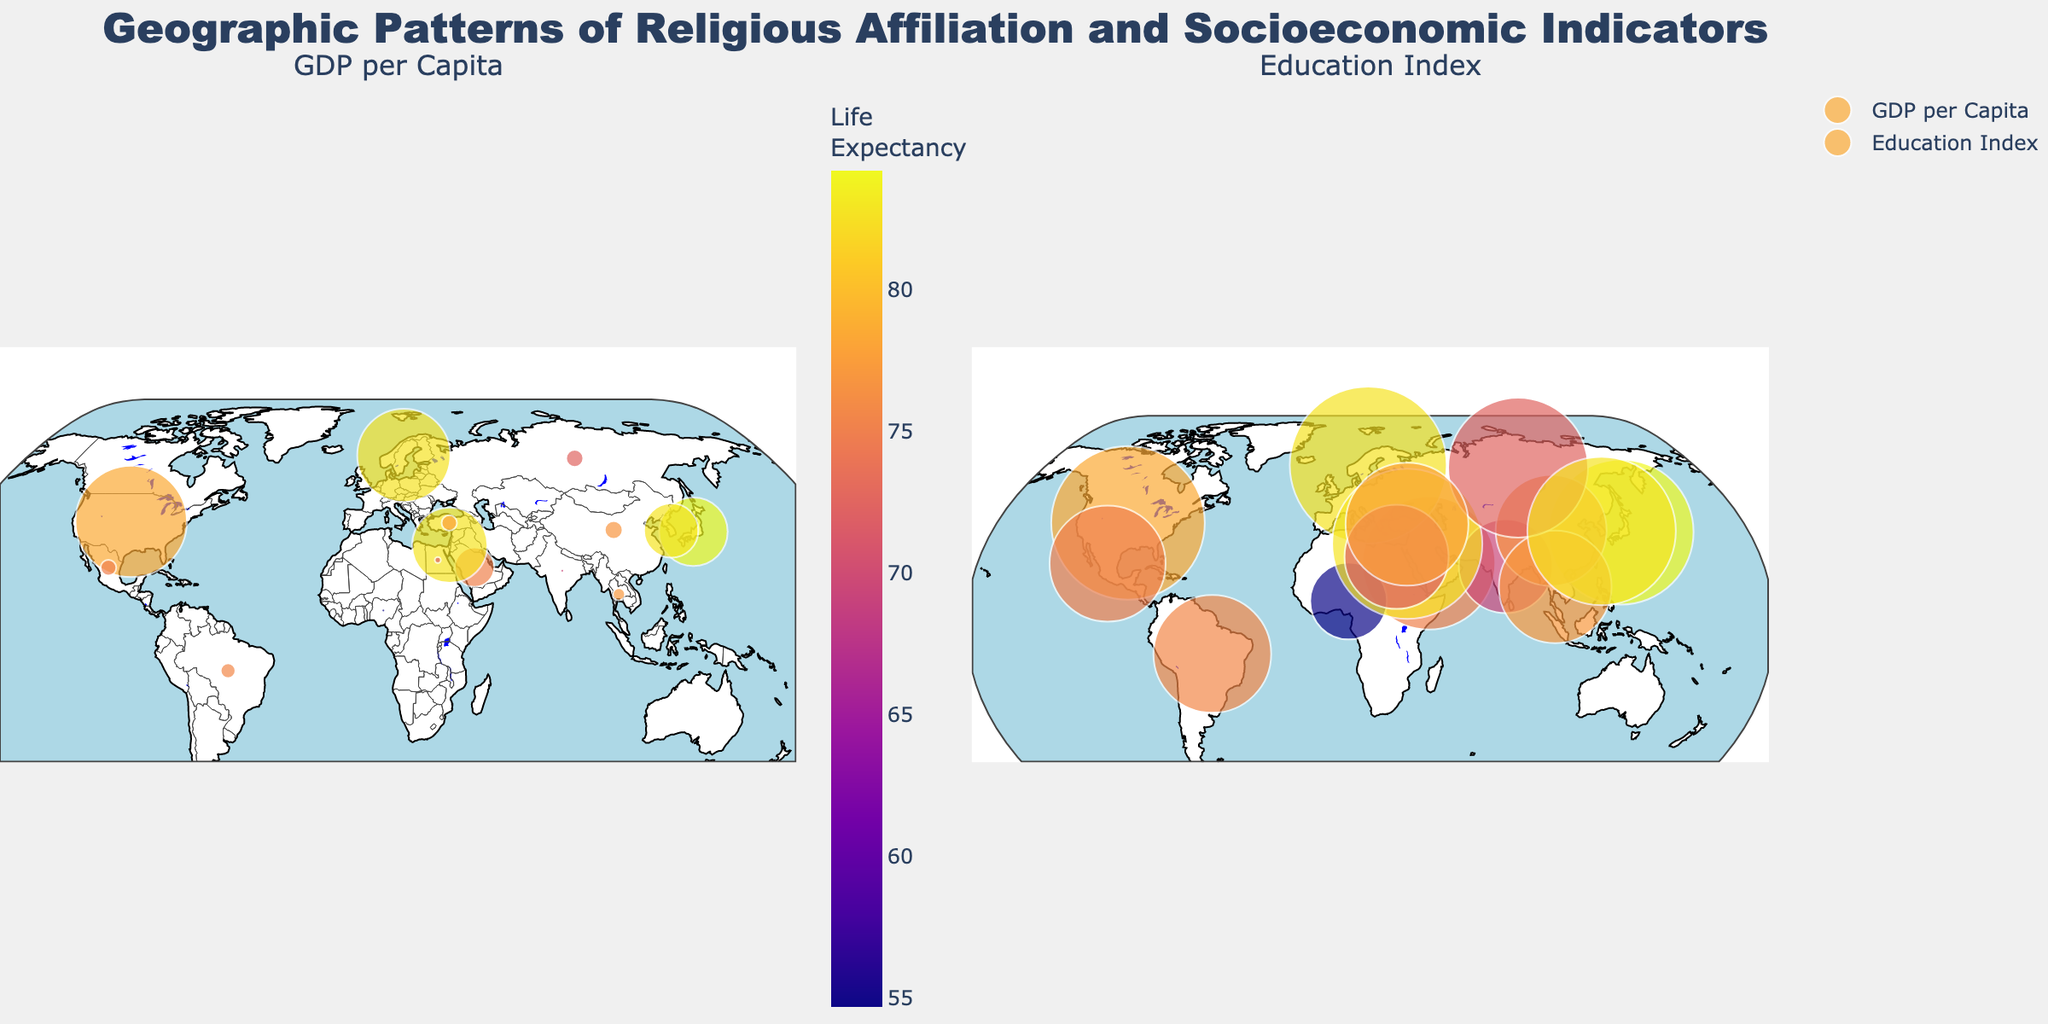What is the title of the plot? The title is usually found at the top of the plot, summarizing the main purpose and data presented. In this plot, it is "Geographic Patterns of Religious Affiliation and Socioeconomic Indicators".
Answer: Geographic Patterns of Religious Affiliation and Socioeconomic Indicators Which country has the highest GDP per capita based on the figure? To find this, look for the data point with the largest marker size on the left subplot (GDP per Capita). The United States has the largest marker, indicating the highest GDP per capita.
Answer: United States What is the religion of the country with the highest education index? First, identify the country with the largest marker size in the right subplot (Education Index). Sweden has the largest marker size indicating the highest education index. Its religion is Non-religious.
Answer: Non-religious Compare the life expectancy in Japan and Nigeria. Which country has a higher value? Locate Japan and Nigeria on either subplot and observe the color scale, where lighter colors indicate higher life expectancy. Japan's color is lighter, indicating a higher life expectancy compared to Nigeria.
Answer: Japan How does GDP per capita correlate with education index across the countries shown? To assess this, compare the marker sizes in both subplots. Generally, countries with larger markers on the GDP subplot also have large markers on the education index subplot, indicating a positive correlation.
Answer: Positive correlation What is the life expectancy range represented in the plots? The color bar on the left subplot indicates the life expectancy range from the minimum to the maximum value represented by colors. It ranges from 54.7 (Nigeria) to 84.2 (Japan).
Answer: 54.7 to 84.2 Which country with Christianity as the main religion has the highest life expectancy? Look at the color of the markers labeled with Christianity on either subplot. South Korea and Israel both show the lightest shades, indicating the highest life expectancy, which is 82.8 years for both. However, South Korea is not majority Christian; therefore, Israel fits the criterion.
Answer: Israel What is the average life expectancy for countries with Islam as the predominant religion? Identify the countries with Islam as the religion and note their life expectancies. These countries are Saudi Arabia (75.1), Nigeria (54.7), Egypt (71.8), and Turkey (77.7). The average is calculated as (75.1 + 54.7 + 71.8 + 77.7) / 4 = 69.83.
Answer: 69.83 How many countries in the plot have a life expectancy above 80 years? Check the color scale and count the number of countries with marker colors representing life expectancies above 80 years: Japan, Sweden, Israel, and South Korea.
Answer: 4 